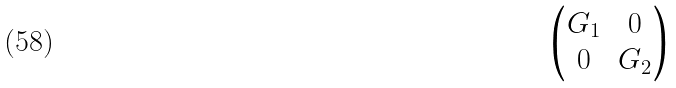Convert formula to latex. <formula><loc_0><loc_0><loc_500><loc_500>\begin{pmatrix} G _ { 1 } & 0 \\ 0 & G _ { 2 } \end{pmatrix}</formula> 